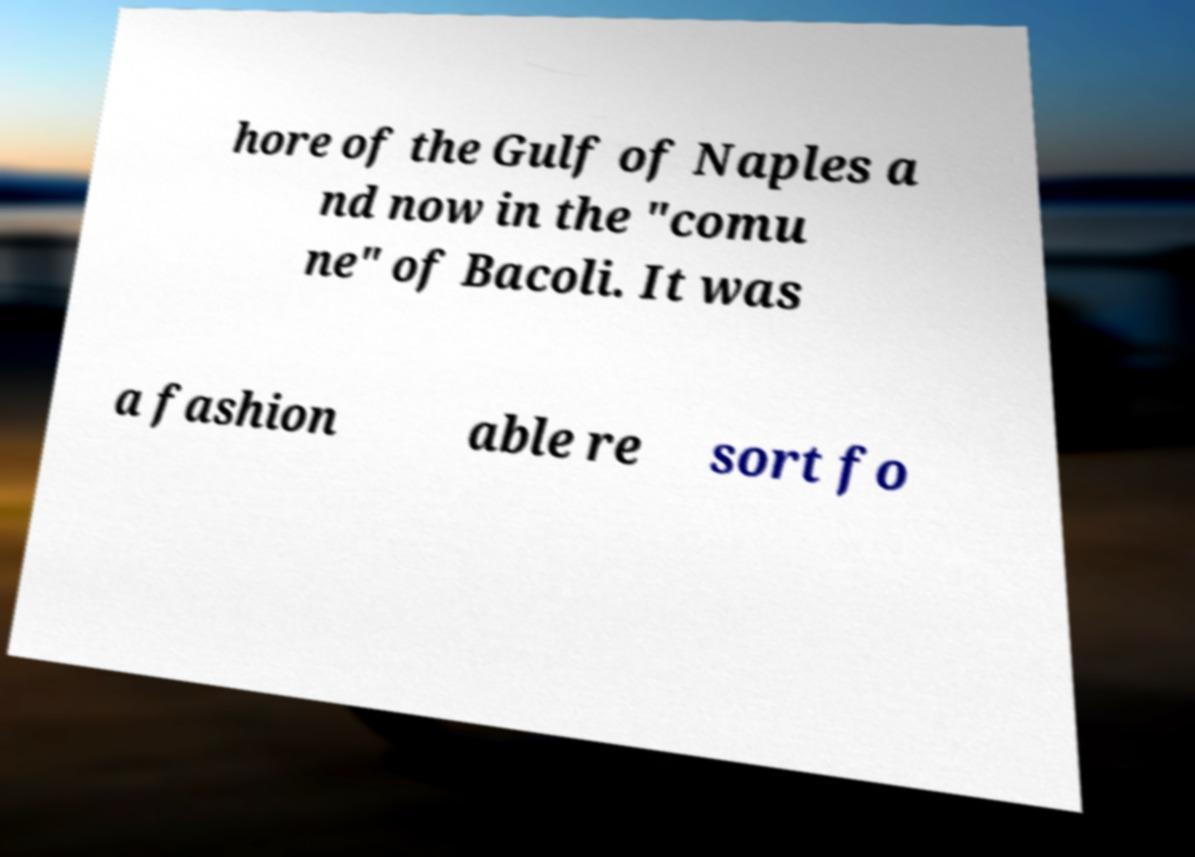Could you extract and type out the text from this image? hore of the Gulf of Naples a nd now in the "comu ne" of Bacoli. It was a fashion able re sort fo 